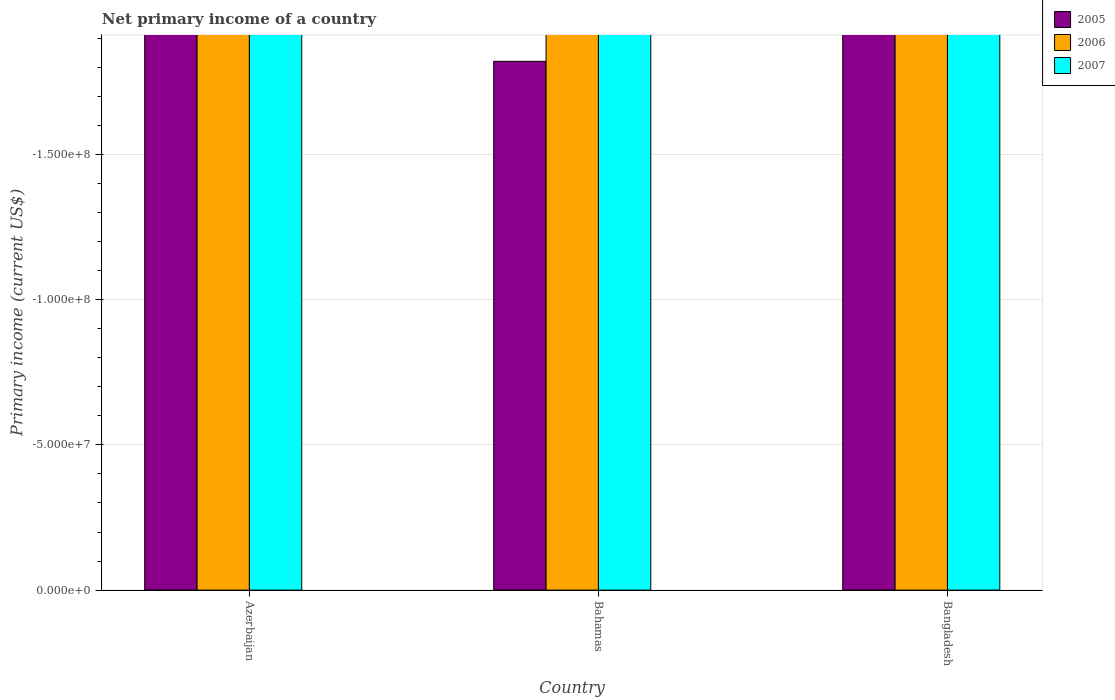How many different coloured bars are there?
Provide a succinct answer. 0. Are the number of bars per tick equal to the number of legend labels?
Make the answer very short. No. How many bars are there on the 2nd tick from the left?
Give a very brief answer. 0. What is the label of the 3rd group of bars from the left?
Ensure brevity in your answer.  Bangladesh. Across all countries, what is the minimum primary income in 2007?
Keep it short and to the point. 0. What is the total primary income in 2006 in the graph?
Your answer should be very brief. 0. What is the average primary income in 2006 per country?
Your response must be concise. 0. Is it the case that in every country, the sum of the primary income in 2006 and primary income in 2007 is greater than the primary income in 2005?
Offer a terse response. No. Are all the bars in the graph horizontal?
Give a very brief answer. No. How many countries are there in the graph?
Give a very brief answer. 3. What is the difference between two consecutive major ticks on the Y-axis?
Your answer should be compact. 5.00e+07. Are the values on the major ticks of Y-axis written in scientific E-notation?
Offer a terse response. Yes. Does the graph contain any zero values?
Make the answer very short. Yes. What is the title of the graph?
Your answer should be compact. Net primary income of a country. Does "2002" appear as one of the legend labels in the graph?
Your answer should be compact. No. What is the label or title of the Y-axis?
Keep it short and to the point. Primary income (current US$). What is the Primary income (current US$) in 2005 in Azerbaijan?
Your answer should be very brief. 0. What is the Primary income (current US$) of 2006 in Azerbaijan?
Your answer should be very brief. 0. What is the Primary income (current US$) in 2007 in Azerbaijan?
Your answer should be very brief. 0. What is the Primary income (current US$) of 2005 in Bangladesh?
Provide a succinct answer. 0. What is the Primary income (current US$) of 2007 in Bangladesh?
Make the answer very short. 0. What is the average Primary income (current US$) of 2006 per country?
Provide a succinct answer. 0. What is the average Primary income (current US$) in 2007 per country?
Provide a succinct answer. 0. 